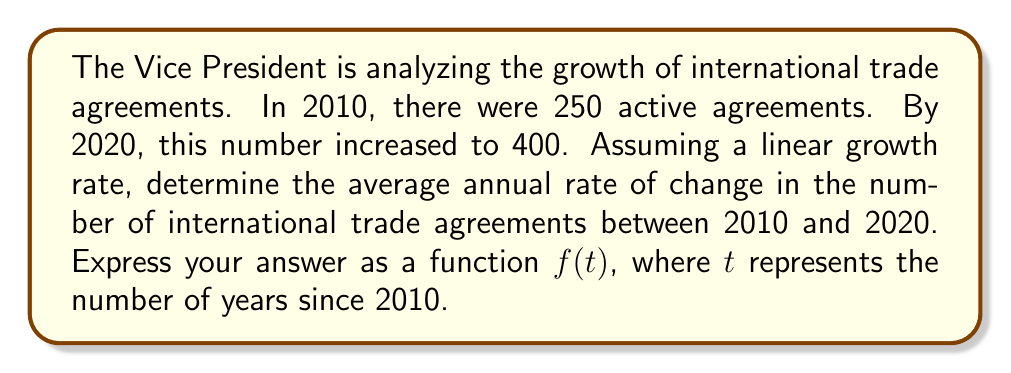Give your solution to this math problem. To solve this problem, we'll follow these steps:

1. Identify the key information:
   - Initial year: 2010
   - Final year: 2020
   - Initial number of agreements: 250
   - Final number of agreements: 400
   - Time period: 10 years

2. Calculate the total change in the number of agreements:
   $\text{Total change} = 400 - 250 = 150$ agreements

3. Calculate the average annual rate of change:
   $$\text{Annual rate} = \frac{\text{Total change}}{\text{Number of years}} = \frac{150}{10} = 15 \text{ agreements per year}$$

4. Express the function $f(t)$ representing the number of agreements $t$ years after 2010:
   $$f(t) = 250 + 15t$$

   Where:
   - 250 is the initial number of agreements in 2010
   - 15 is the annual rate of change
   - $t$ is the number of years since 2010

5. Verify the function:
   - At $t = 0$ (2010): $f(0) = 250 + 15(0) = 250$
   - At $t = 10$ (2020): $f(10) = 250 + 15(10) = 400$

Therefore, the function $f(t) = 250 + 15t$ correctly represents the average annual rate of change in international trade agreements over time, where $t$ is the number of years since 2010.
Answer: $f(t) = 250 + 15t$ 